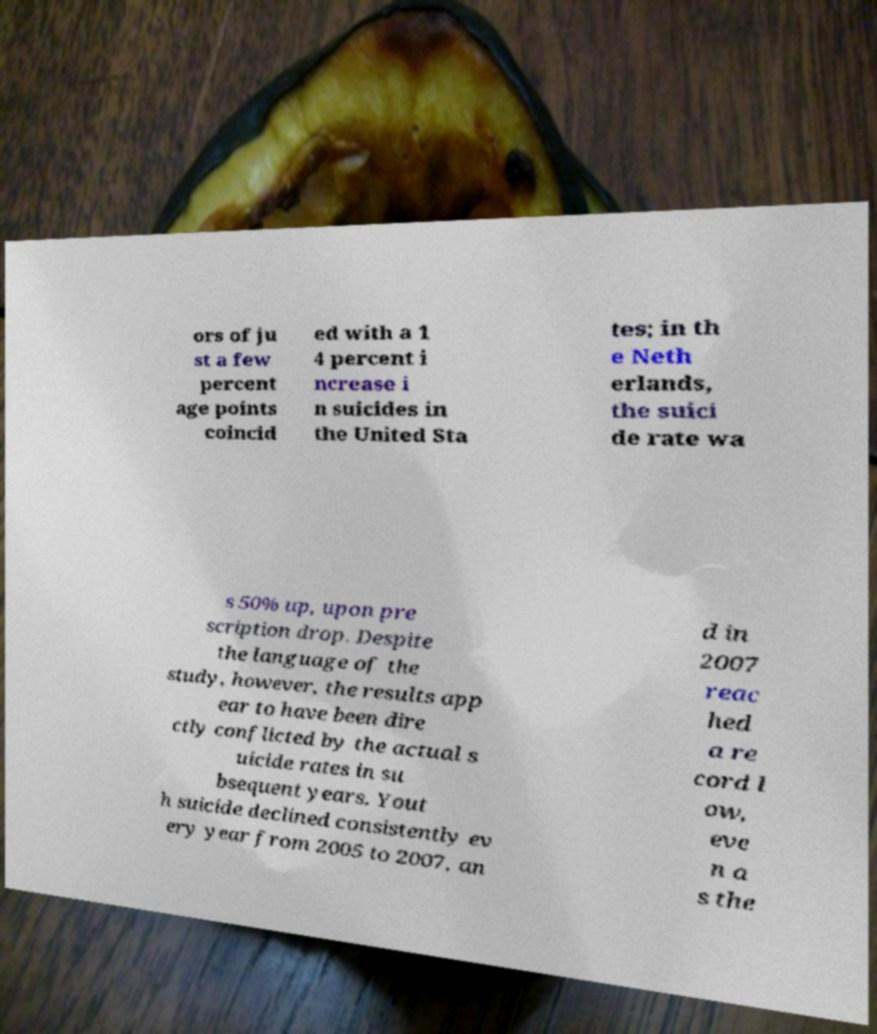Please identify and transcribe the text found in this image. ors of ju st a few percent age points coincid ed with a 1 4 percent i ncrease i n suicides in the United Sta tes; in th e Neth erlands, the suici de rate wa s 50% up, upon pre scription drop. Despite the language of the study, however, the results app ear to have been dire ctly conflicted by the actual s uicide rates in su bsequent years. Yout h suicide declined consistently ev ery year from 2005 to 2007, an d in 2007 reac hed a re cord l ow, eve n a s the 